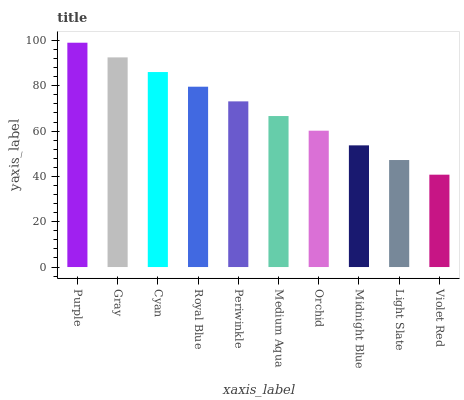Is Violet Red the minimum?
Answer yes or no. Yes. Is Purple the maximum?
Answer yes or no. Yes. Is Gray the minimum?
Answer yes or no. No. Is Gray the maximum?
Answer yes or no. No. Is Purple greater than Gray?
Answer yes or no. Yes. Is Gray less than Purple?
Answer yes or no. Yes. Is Gray greater than Purple?
Answer yes or no. No. Is Purple less than Gray?
Answer yes or no. No. Is Periwinkle the high median?
Answer yes or no. Yes. Is Medium Aqua the low median?
Answer yes or no. Yes. Is Light Slate the high median?
Answer yes or no. No. Is Royal Blue the low median?
Answer yes or no. No. 